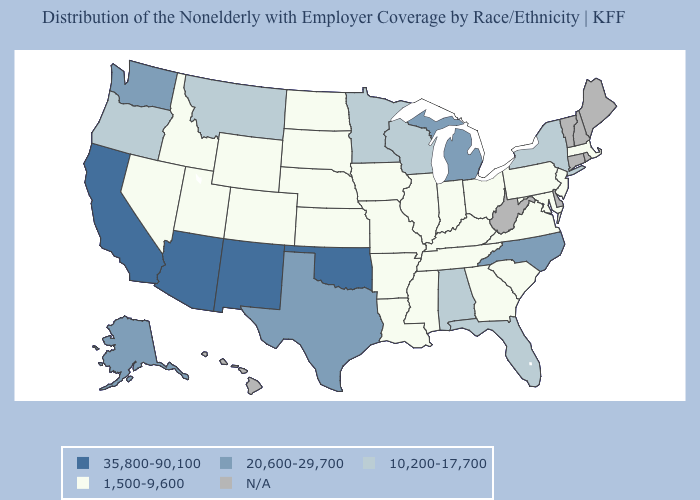Which states hav the highest value in the South?
Short answer required. Oklahoma. Among the states that border Ohio , does Pennsylvania have the highest value?
Write a very short answer. No. Does the map have missing data?
Give a very brief answer. Yes. Which states hav the highest value in the MidWest?
Give a very brief answer. Michigan. How many symbols are there in the legend?
Keep it brief. 5. Name the states that have a value in the range N/A?
Be succinct. Connecticut, Delaware, Hawaii, Maine, New Hampshire, Rhode Island, Vermont, West Virginia. What is the value of Idaho?
Quick response, please. 1,500-9,600. Name the states that have a value in the range 10,200-17,700?
Give a very brief answer. Alabama, Florida, Minnesota, Montana, New York, Oregon, Wisconsin. How many symbols are there in the legend?
Short answer required. 5. Does Michigan have the lowest value in the MidWest?
Answer briefly. No. Name the states that have a value in the range 1,500-9,600?
Short answer required. Arkansas, Colorado, Georgia, Idaho, Illinois, Indiana, Iowa, Kansas, Kentucky, Louisiana, Maryland, Massachusetts, Mississippi, Missouri, Nebraska, Nevada, New Jersey, North Dakota, Ohio, Pennsylvania, South Carolina, South Dakota, Tennessee, Utah, Virginia, Wyoming. What is the highest value in states that border Maryland?
Short answer required. 1,500-9,600. Does the first symbol in the legend represent the smallest category?
Answer briefly. No. Name the states that have a value in the range 1,500-9,600?
Concise answer only. Arkansas, Colorado, Georgia, Idaho, Illinois, Indiana, Iowa, Kansas, Kentucky, Louisiana, Maryland, Massachusetts, Mississippi, Missouri, Nebraska, Nevada, New Jersey, North Dakota, Ohio, Pennsylvania, South Carolina, South Dakota, Tennessee, Utah, Virginia, Wyoming. 